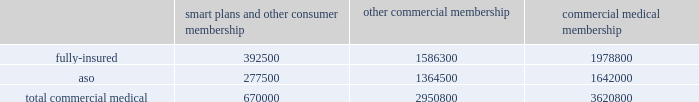Va health care delivery system through our network of providers .
We are compensated by the va for the cost of our providers 2019 services at a specified contractual amount per service plus an additional administrative fee for each transaction .
The contract , under which we began providing services on january 1 , 2008 , is comprised of one base period and four one-year option periods subject to renewals at the federal government 2019s option .
We are currently in the first option period , which expires on september 30 , 2009 .
For the year ended december 31 , 2008 , revenues under this va contract were approximately $ 22.7 million , or less than 1% ( 1 % ) of our total premium and aso fees .
For the year ended december 31 , 2008 , military services premium revenues were approximately $ 3.2 billion , or 11.3% ( 11.3 % ) of our total premiums and aso fees , and military services aso fees totaled $ 76.8 million , or 0.3% ( 0.3 % ) of our total premiums and aso fees .
International and green ribbon health operations in august 2006 , we established our subsidiary humana europe in the united kingdom to provide commissioning support to primary care trusts , or pcts , in england .
Under the contracts we are awarded , we work in partnership with local pcts , health care providers , and patients to strengthen health-service delivery and to implement strategies at a local level to help the national health service enhance patient experience , improve clinical outcomes , and reduce costs .
For the year ended december 31 , 2008 , revenues under these contracts were approximately $ 7.7 million , or less than 1% ( 1 % ) of our total premium and aso fees .
We participated in a medicare health support pilot program through green ribbon health , or grh , a joint- venture company with pfizer health solutions inc .
Grh was designed to support cms assigned medicare beneficiaries living with diabetes and/or congestive heart failure in central florida .
Grh used disease management initiatives , including evidence-based clinical guidelines , personal self-directed change strategies , and personal nurses to help participants navigate the health system .
Revenues under the contract with cms over the period which began november 1 , 2005 and ended august 15 , 2008 are subject to refund unless savings , satisfaction , and clinical improvement targets are met .
Under the terms of the contract , after a claims run-out period , cms is required to deliver a performance report during the third quarter of 2009 .
To date , all revenues have been deferred until reliable estimates are determinable , and revenues are not expected to be material when recognized .
Our products marketed to commercial segment employers and members smart plans and other consumer products over the last several years , we have developed and offered various commercial products designed to provide options and choices to employers that are annually facing substantial premium increases driven by double-digit medical cost inflation .
These smart plans , discussed more fully below , and other consumer offerings , which can be offered on either a fully-insured or aso basis , provided coverage to approximately 670000 members at december 31 , 2008 , representing approximately 18.5% ( 18.5 % ) of our total commercial medical membership as detailed below .
Smart plans and other consumer membership other commercial membership commercial medical membership .
These products are often offered to employer groups as 201cbundles 201d , where the subscribers are offered various hmo and ppo options , with various employer contribution strategies as determined by the employer. .
What is the average number of aso memberships? 
Rationale: it is the sum of both types of memberships , then divided by two to represent the average .
Computations: ((277500 + 1364500) / 2)
Answer: 821000.0. 